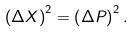<formula> <loc_0><loc_0><loc_500><loc_500>\left ( \Delta X \right ) ^ { 2 } = \left ( \Delta P \right ) ^ { 2 } .</formula> 